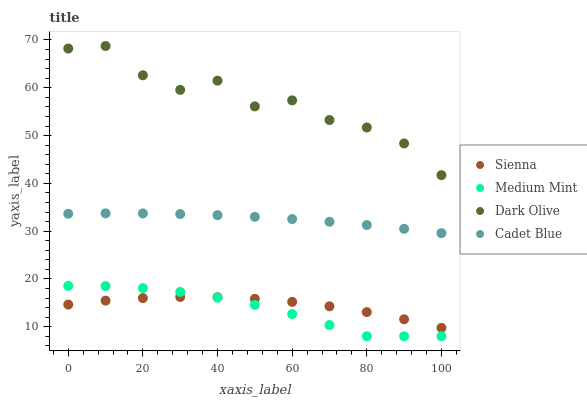Does Medium Mint have the minimum area under the curve?
Answer yes or no. Yes. Does Dark Olive have the maximum area under the curve?
Answer yes or no. Yes. Does Dark Olive have the minimum area under the curve?
Answer yes or no. No. Does Medium Mint have the maximum area under the curve?
Answer yes or no. No. Is Cadet Blue the smoothest?
Answer yes or no. Yes. Is Dark Olive the roughest?
Answer yes or no. Yes. Is Medium Mint the smoothest?
Answer yes or no. No. Is Medium Mint the roughest?
Answer yes or no. No. Does Medium Mint have the lowest value?
Answer yes or no. Yes. Does Dark Olive have the lowest value?
Answer yes or no. No. Does Dark Olive have the highest value?
Answer yes or no. Yes. Does Medium Mint have the highest value?
Answer yes or no. No. Is Sienna less than Cadet Blue?
Answer yes or no. Yes. Is Dark Olive greater than Sienna?
Answer yes or no. Yes. Does Medium Mint intersect Sienna?
Answer yes or no. Yes. Is Medium Mint less than Sienna?
Answer yes or no. No. Is Medium Mint greater than Sienna?
Answer yes or no. No. Does Sienna intersect Cadet Blue?
Answer yes or no. No. 